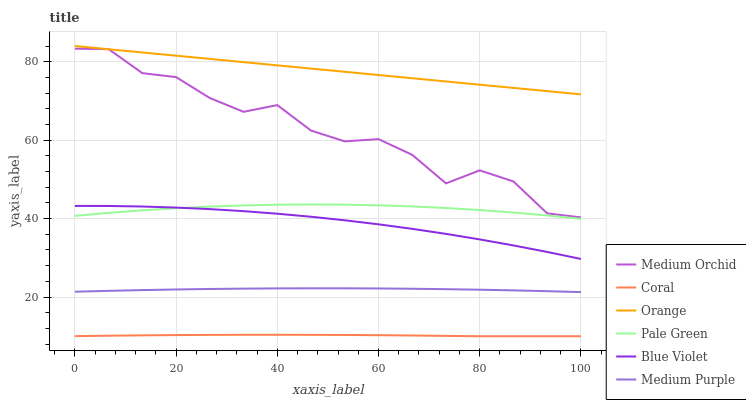Does Coral have the minimum area under the curve?
Answer yes or no. Yes. Does Orange have the maximum area under the curve?
Answer yes or no. Yes. Does Medium Orchid have the minimum area under the curve?
Answer yes or no. No. Does Medium Orchid have the maximum area under the curve?
Answer yes or no. No. Is Orange the smoothest?
Answer yes or no. Yes. Is Medium Orchid the roughest?
Answer yes or no. Yes. Is Medium Purple the smoothest?
Answer yes or no. No. Is Medium Purple the roughest?
Answer yes or no. No. Does Coral have the lowest value?
Answer yes or no. Yes. Does Medium Orchid have the lowest value?
Answer yes or no. No. Does Orange have the highest value?
Answer yes or no. Yes. Does Medium Orchid have the highest value?
Answer yes or no. No. Is Medium Purple less than Blue Violet?
Answer yes or no. Yes. Is Pale Green greater than Coral?
Answer yes or no. Yes. Does Orange intersect Medium Orchid?
Answer yes or no. Yes. Is Orange less than Medium Orchid?
Answer yes or no. No. Is Orange greater than Medium Orchid?
Answer yes or no. No. Does Medium Purple intersect Blue Violet?
Answer yes or no. No. 